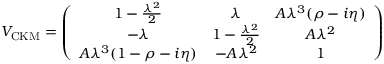<formula> <loc_0><loc_0><loc_500><loc_500>V _ { C K M } = \left ( \begin{array} { c c c } { { 1 - \frac { \lambda ^ { 2 } } { 2 } } } & { \lambda } & { { A \lambda ^ { 3 } ( \rho - i \eta ) } } \\ { - \lambda } & { { 1 - \frac { \lambda ^ { 2 } } { 2 } } } & { { A \lambda ^ { 2 } } } \\ { { A \lambda ^ { 3 } ( 1 - \rho - i \eta ) } } & { { - A \lambda ^ { 2 } } } & { 1 } \end{array} \right )</formula> 